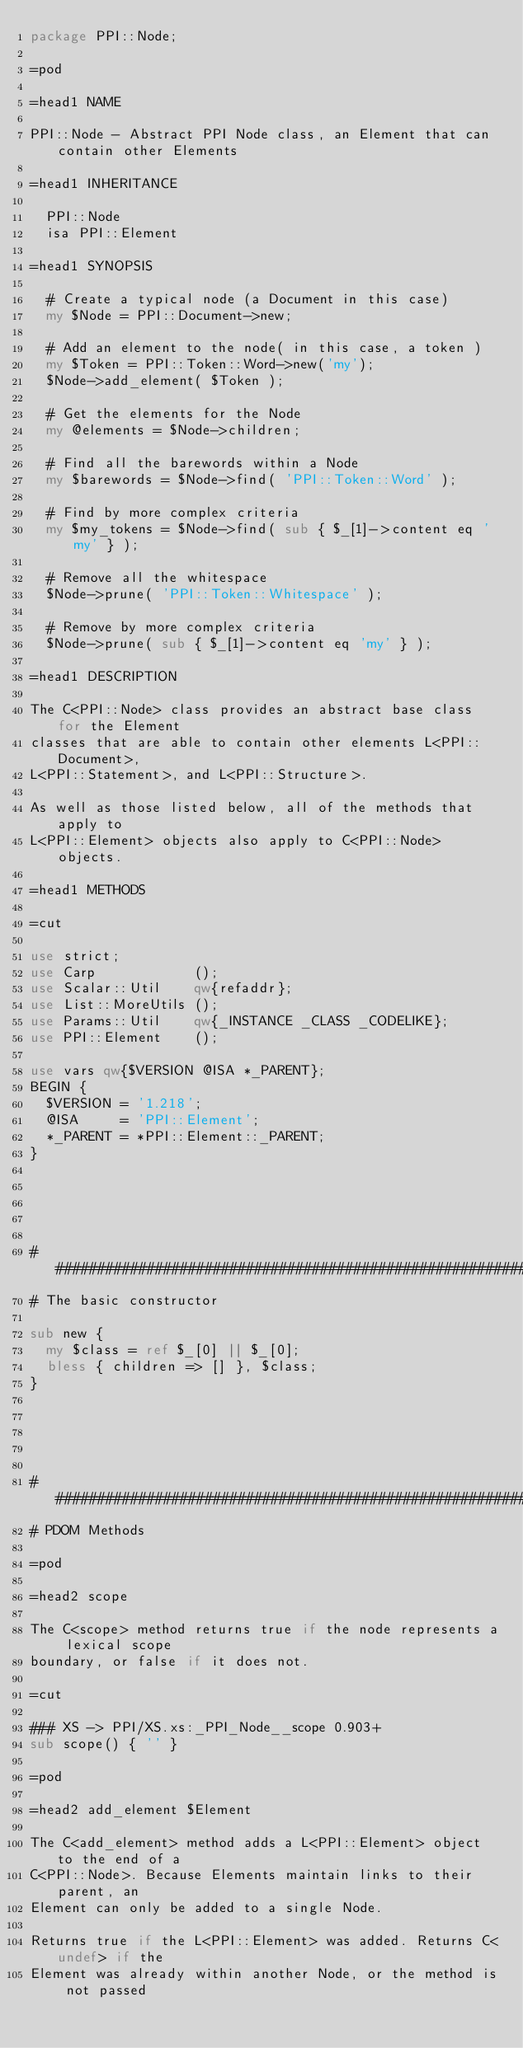Convert code to text. <code><loc_0><loc_0><loc_500><loc_500><_Perl_>package PPI::Node;

=pod

=head1 NAME

PPI::Node - Abstract PPI Node class, an Element that can contain other Elements

=head1 INHERITANCE

  PPI::Node
  isa PPI::Element

=head1 SYNOPSIS

  # Create a typical node (a Document in this case)
  my $Node = PPI::Document->new;
  
  # Add an element to the node( in this case, a token )
  my $Token = PPI::Token::Word->new('my');
  $Node->add_element( $Token );
  
  # Get the elements for the Node
  my @elements = $Node->children;
  
  # Find all the barewords within a Node
  my $barewords = $Node->find( 'PPI::Token::Word' );
  
  # Find by more complex criteria
  my $my_tokens = $Node->find( sub { $_[1]->content eq 'my' } );
  
  # Remove all the whitespace
  $Node->prune( 'PPI::Token::Whitespace' );
  
  # Remove by more complex criteria
  $Node->prune( sub { $_[1]->content eq 'my' } );

=head1 DESCRIPTION

The C<PPI::Node> class provides an abstract base class for the Element
classes that are able to contain other elements L<PPI::Document>,
L<PPI::Statement>, and L<PPI::Structure>.

As well as those listed below, all of the methods that apply to
L<PPI::Element> objects also apply to C<PPI::Node> objects.

=head1 METHODS

=cut

use strict;
use Carp            ();
use Scalar::Util    qw{refaddr};
use List::MoreUtils ();
use Params::Util    qw{_INSTANCE _CLASS _CODELIKE};
use PPI::Element    ();

use vars qw{$VERSION @ISA *_PARENT};
BEGIN {
	$VERSION = '1.218';
	@ISA     = 'PPI::Element';
	*_PARENT = *PPI::Element::_PARENT;
}





#####################################################################
# The basic constructor

sub new {
	my $class = ref $_[0] || $_[0];
	bless { children => [] }, $class;
}





#####################################################################
# PDOM Methods

=pod

=head2 scope

The C<scope> method returns true if the node represents a lexical scope
boundary, or false if it does not.

=cut

### XS -> PPI/XS.xs:_PPI_Node__scope 0.903+
sub scope() { '' }

=pod

=head2 add_element $Element

The C<add_element> method adds a L<PPI::Element> object to the end of a
C<PPI::Node>. Because Elements maintain links to their parent, an
Element can only be added to a single Node.

Returns true if the L<PPI::Element> was added. Returns C<undef> if the
Element was already within another Node, or the method is not passed </code> 